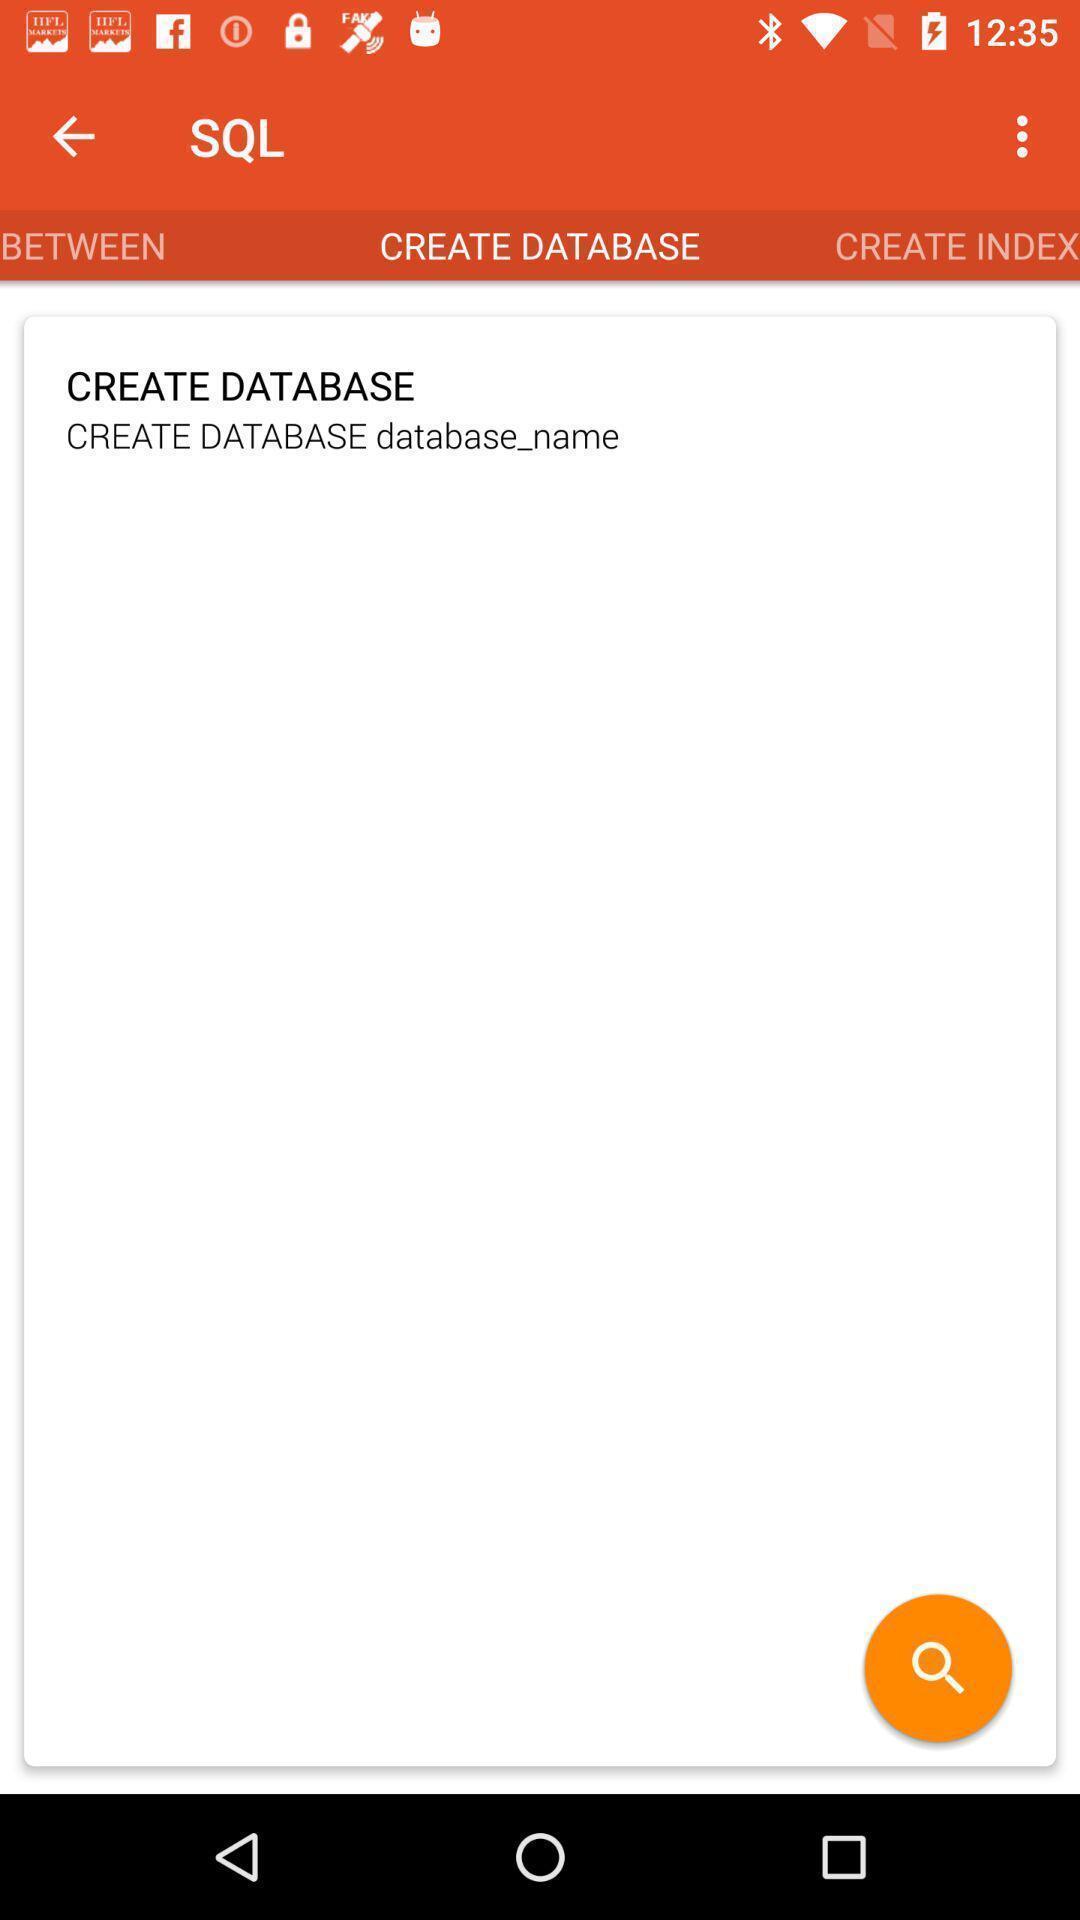Tell me what you see in this picture. Screen shows database page. 